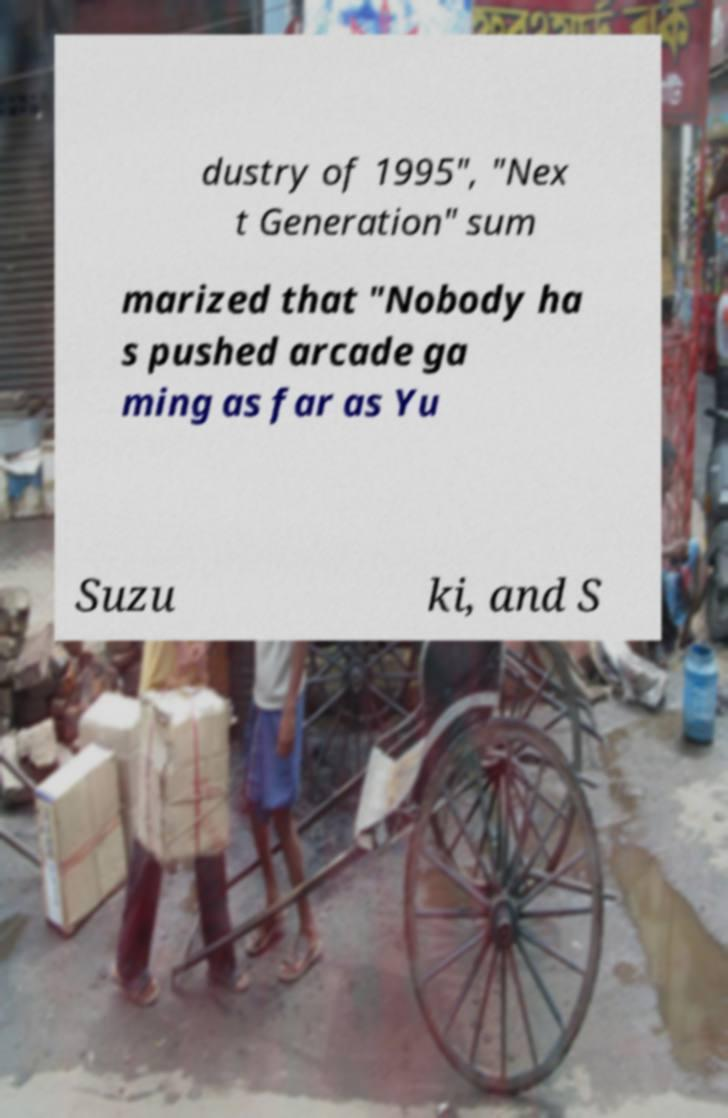For documentation purposes, I need the text within this image transcribed. Could you provide that? dustry of 1995", "Nex t Generation" sum marized that "Nobody ha s pushed arcade ga ming as far as Yu Suzu ki, and S 